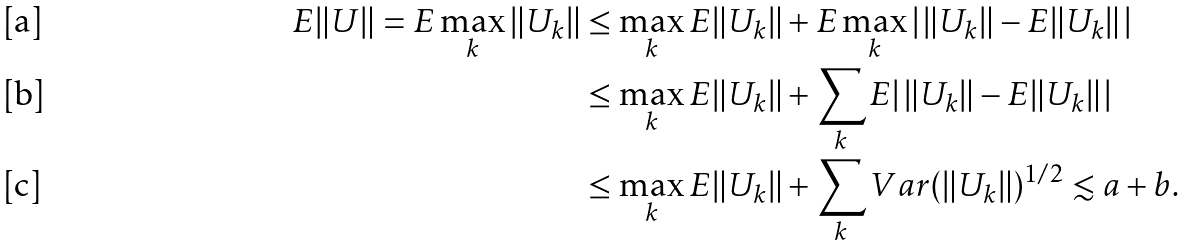<formula> <loc_0><loc_0><loc_500><loc_500>E \| U \| = E \max _ { k } \| U _ { k } \| & \leq \max _ { k } E \| U _ { k } \| + E \max _ { k } | \, \| U _ { k } \| - E \| U _ { k } \| \, | \\ & \leq \max _ { k } E \| U _ { k } \| + \sum _ { k } E | \, \| U _ { k } \| - E \| U _ { k } \| \, | \\ & \leq \max _ { k } E \| U _ { k } \| + \sum _ { k } V a r ( \| U _ { k } \| ) ^ { 1 / 2 } \lesssim a + b .</formula> 